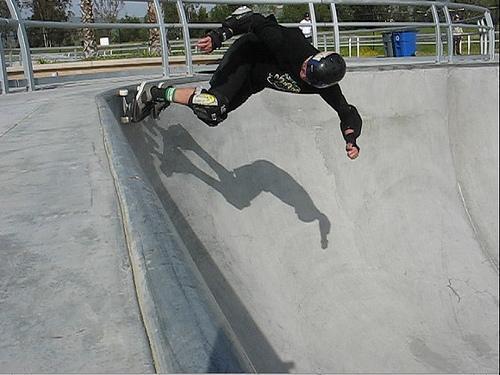How many people can you see?
Give a very brief answer. 1. How many bottles is the lady touching?
Give a very brief answer. 0. 